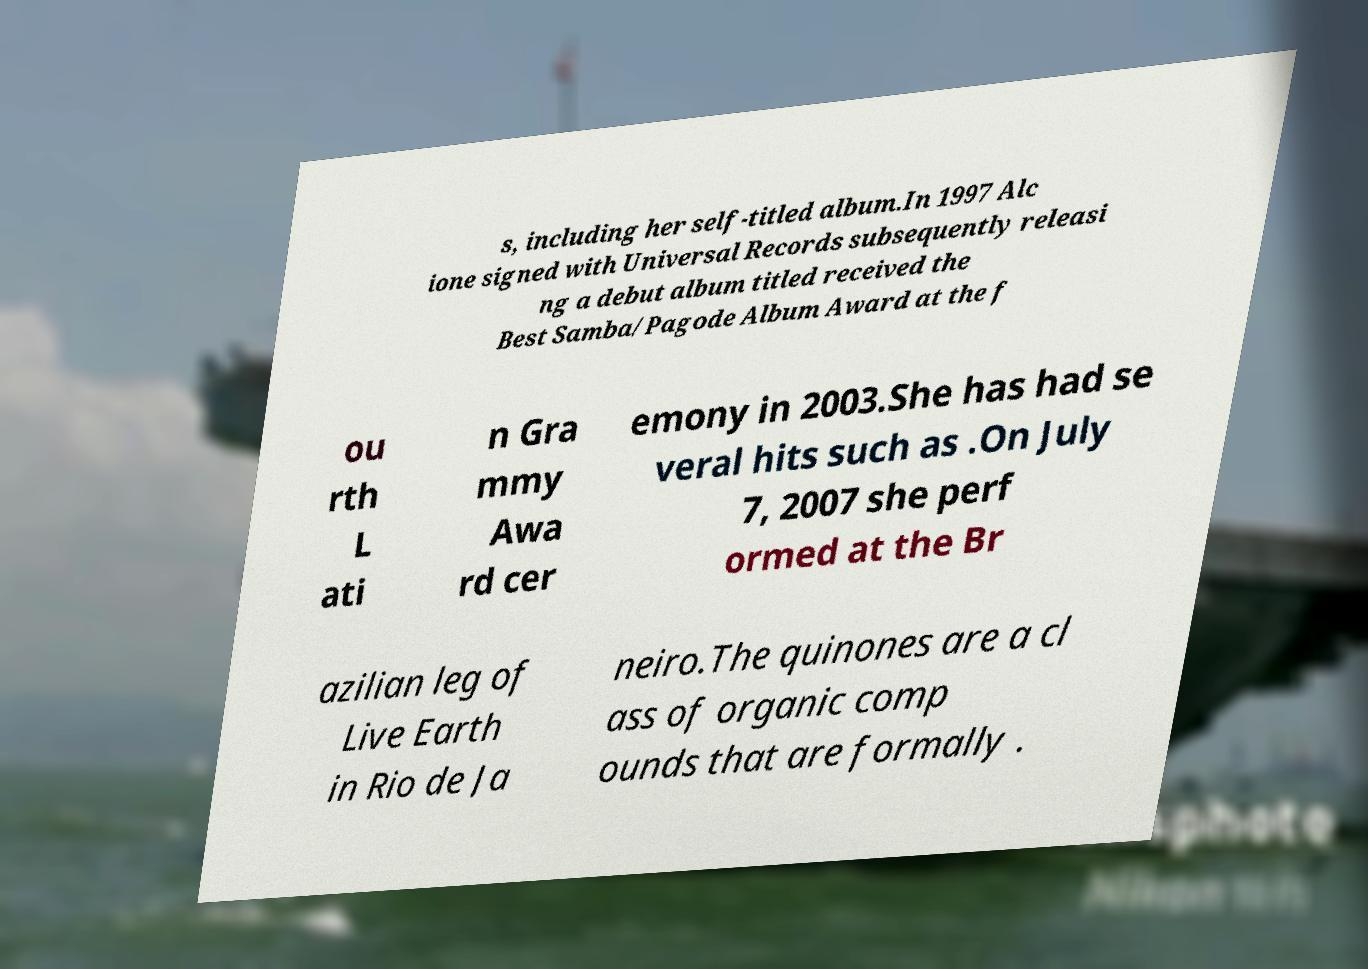Please identify and transcribe the text found in this image. s, including her self-titled album.In 1997 Alc ione signed with Universal Records subsequently releasi ng a debut album titled received the Best Samba/Pagode Album Award at the f ou rth L ati n Gra mmy Awa rd cer emony in 2003.She has had se veral hits such as .On July 7, 2007 she perf ormed at the Br azilian leg of Live Earth in Rio de Ja neiro.The quinones are a cl ass of organic comp ounds that are formally . 